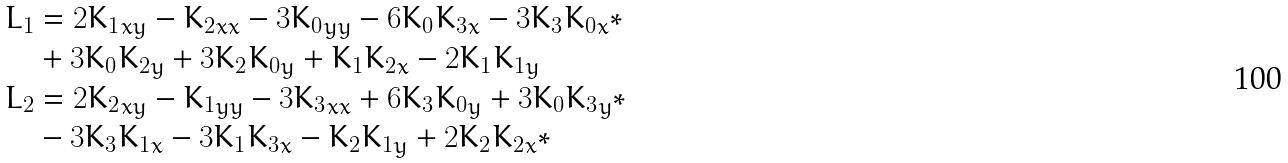Convert formula to latex. <formula><loc_0><loc_0><loc_500><loc_500>L _ { 1 } & = 2 { K _ { 1 } } _ { x y } - { K _ { 2 } } _ { x x } - 3 { K _ { 0 } } _ { y y } - 6 K _ { 0 } { K _ { 3 } } _ { x } - 3 K _ { 3 } { K _ { 0 } } _ { x } * \\ & + 3 K _ { 0 } { K _ { 2 } } _ { y } + 3 K _ { 2 } { K _ { 0 } } _ { y } + { K _ { 1 } } { K _ { 2 } } _ { x } - 2 { K _ { 1 } } { K _ { 1 } } _ { y } \\ L _ { 2 } & = 2 { K _ { 2 } } _ { x y } - { K _ { 1 } } _ { y y } - 3 { K _ { 3 } } _ { x x } + 6 K _ { 3 } { K _ { 0 } } _ { y } + 3 { K _ { 0 } } { K _ { 3 } } _ { y } * \\ & - 3 K _ { 3 } { K _ { 1 } } _ { x } - 3 K _ { 1 } { K _ { 3 } } _ { x } - { K _ { 2 } } { K _ { 1 } } _ { y } + 2 { K _ { 2 } } { K _ { 2 } } _ { x } *</formula> 